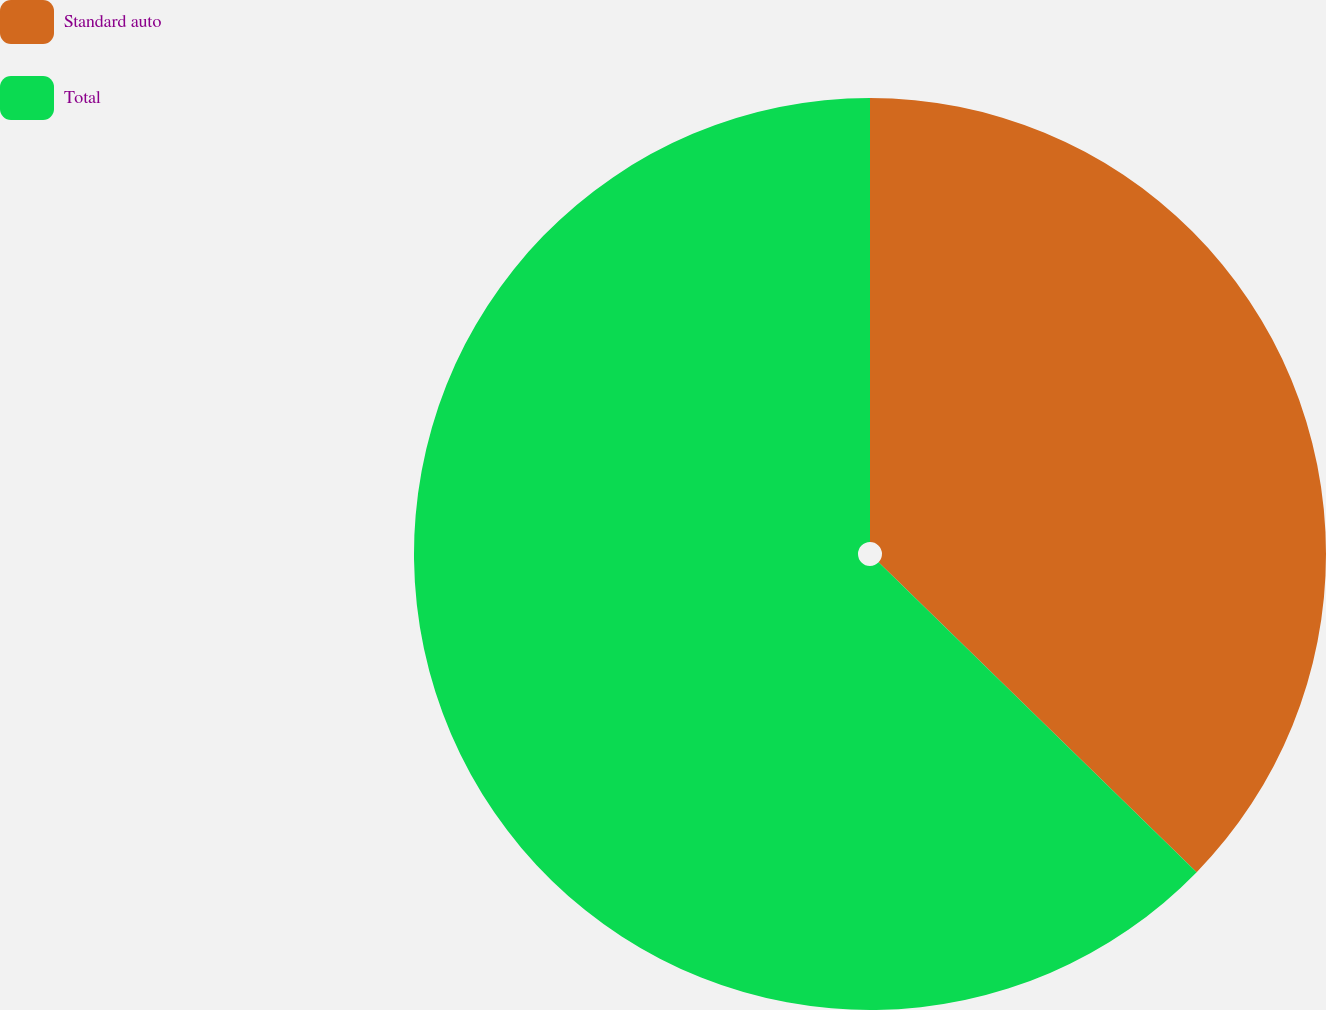Convert chart to OTSL. <chart><loc_0><loc_0><loc_500><loc_500><pie_chart><fcel>Standard auto<fcel>Total<nl><fcel>37.29%<fcel>62.71%<nl></chart> 